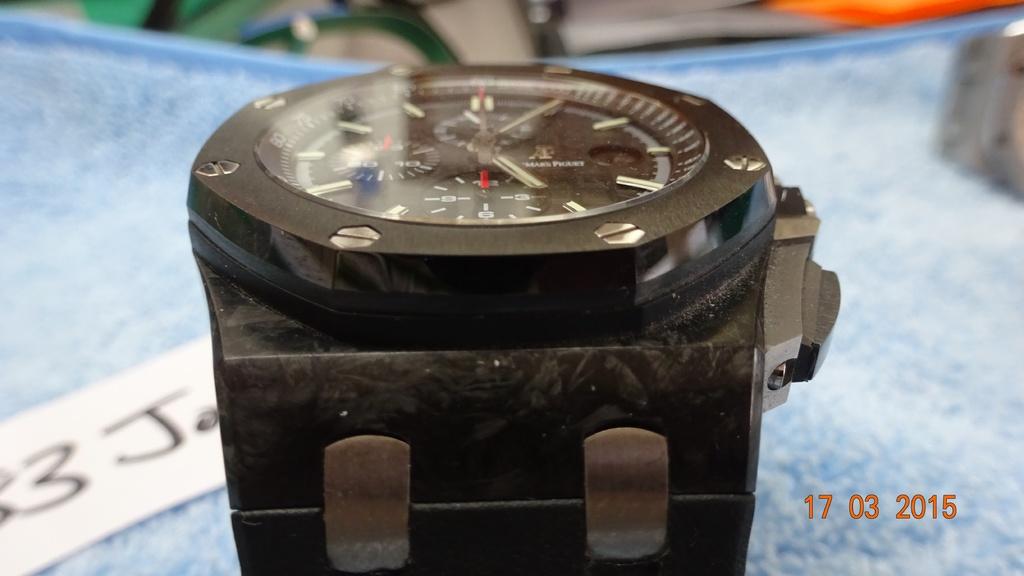What's the date on the right of the photo?
Your response must be concise. 17 03 2015. 